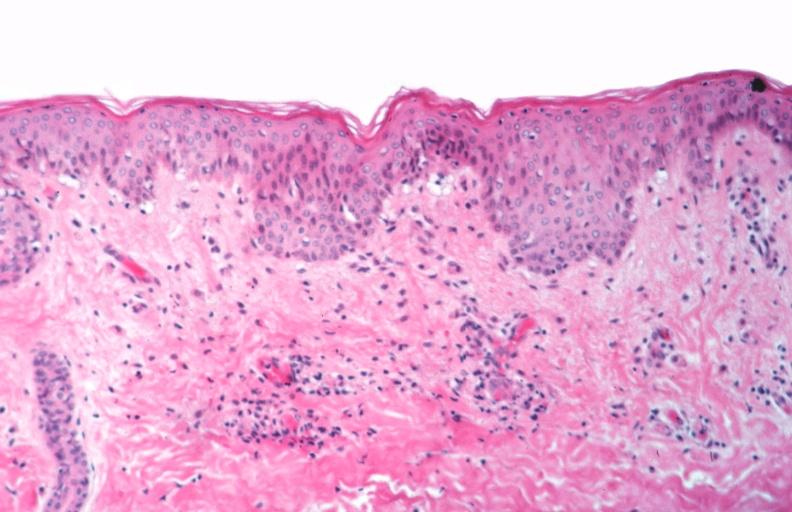s benign cystic teratoma spotted fever, vasculitis?
Answer the question using a single word or phrase. No 